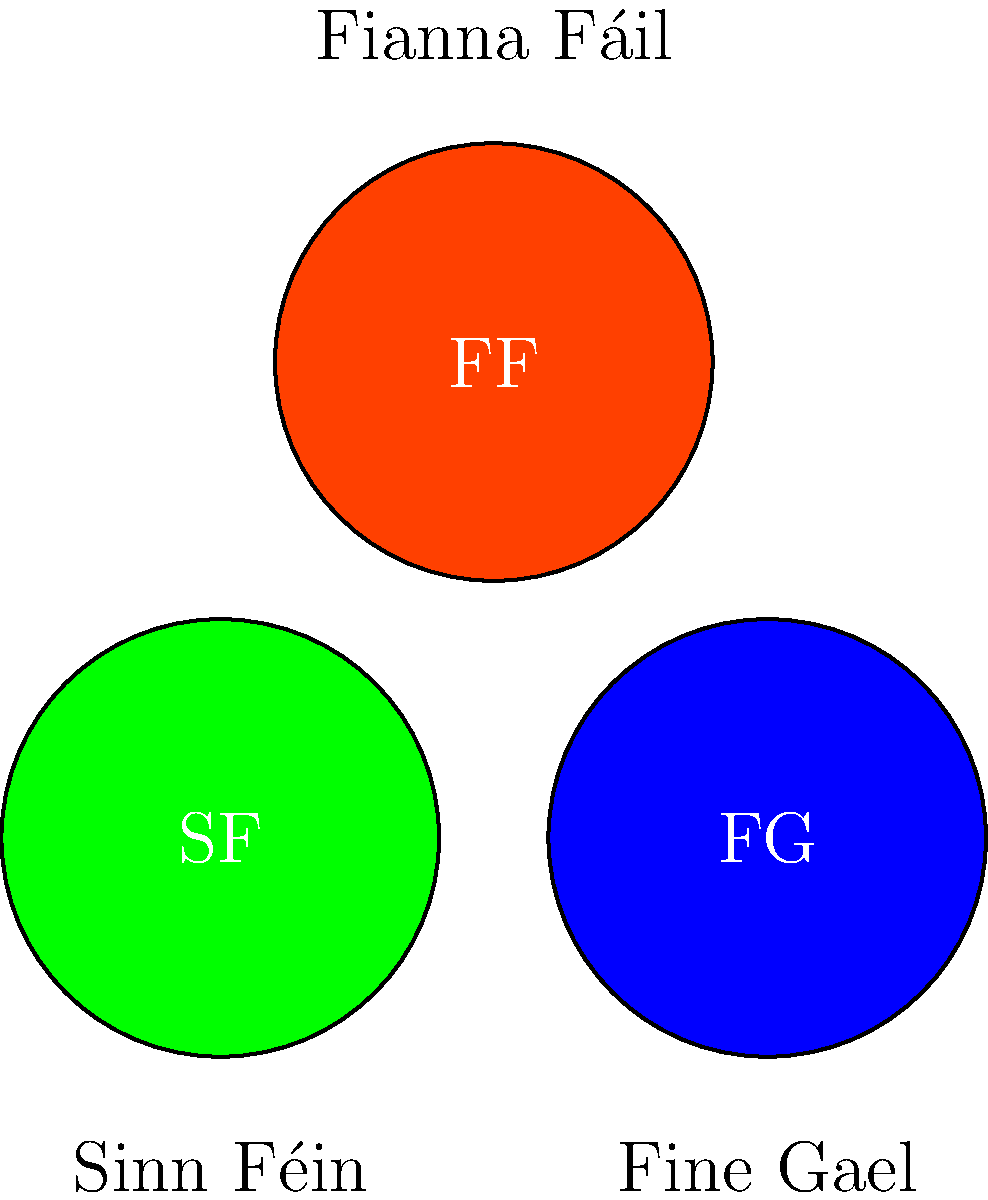Analyze the visual impact of the three main Irish political party logos shown above. Which party's logo color scheme might be most effective in capturing attention on social media platforms, and why would this be particularly relevant for a political blogger advocating for change in Ireland? 1. Sinn Féin (SF): Green logo
   - Green is associated with Ireland's national identity and nature.
   - It's a calming color but may not stand out as much on social media.

2. Fine Gael (FG): Blue logo
   - Blue conveys trust and stability.
   - It's a common color in social media platforms (e.g., Facebook, Twitter), which might make it blend in.

3. Fianna Fáil (FF): Red and orange logo
   - Red is attention-grabbing and associated with energy and passion.
   - Orange adds warmth and friendliness.
   - The combination is unique among the three and likely to stand out.

For a political blogger advocating for change:
1. Attention-grabbing is crucial on social media to cut through the noise.
2. The red and orange combination of Fianna Fáil is most likely to catch users' eyes while scrolling.
3. This color scheme aligns with the idea of change, as red often symbolizes revolution or transformation.
4. The uniqueness of the color combination among Irish parties helps differentiate the content.
5. Warm colors like red and orange tend to increase engagement rates on social media platforms.

Therefore, from a visual impact perspective on social media, the Fianna Fáil logo color scheme would likely be most effective for a political blogger advocating for change in Ireland.
Answer: Fianna Fáil's red and orange logo, due to its attention-grabbing colors and uniqueness among Irish parties, aligning with themes of change and increased social media engagement. 